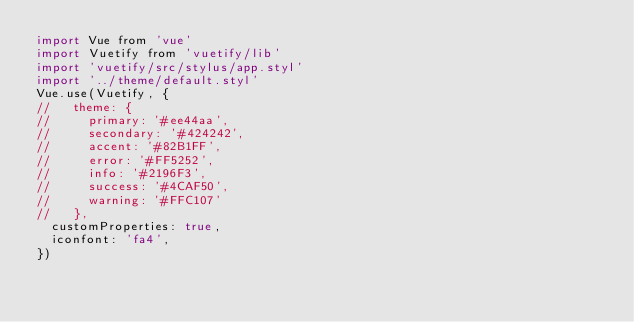Convert code to text. <code><loc_0><loc_0><loc_500><loc_500><_JavaScript_>import Vue from 'vue'
import Vuetify from 'vuetify/lib'
import 'vuetify/src/stylus/app.styl'
import '../theme/default.styl'
Vue.use(Vuetify, {
//   theme: {
//     primary: '#ee44aa',
//     secondary: '#424242',
//     accent: '#82B1FF',
//     error: '#FF5252',
//     info: '#2196F3',
//     success: '#4CAF50',
//     warning: '#FFC107'
//   },
  customProperties: true,
  iconfont: 'fa4',
})
</code> 